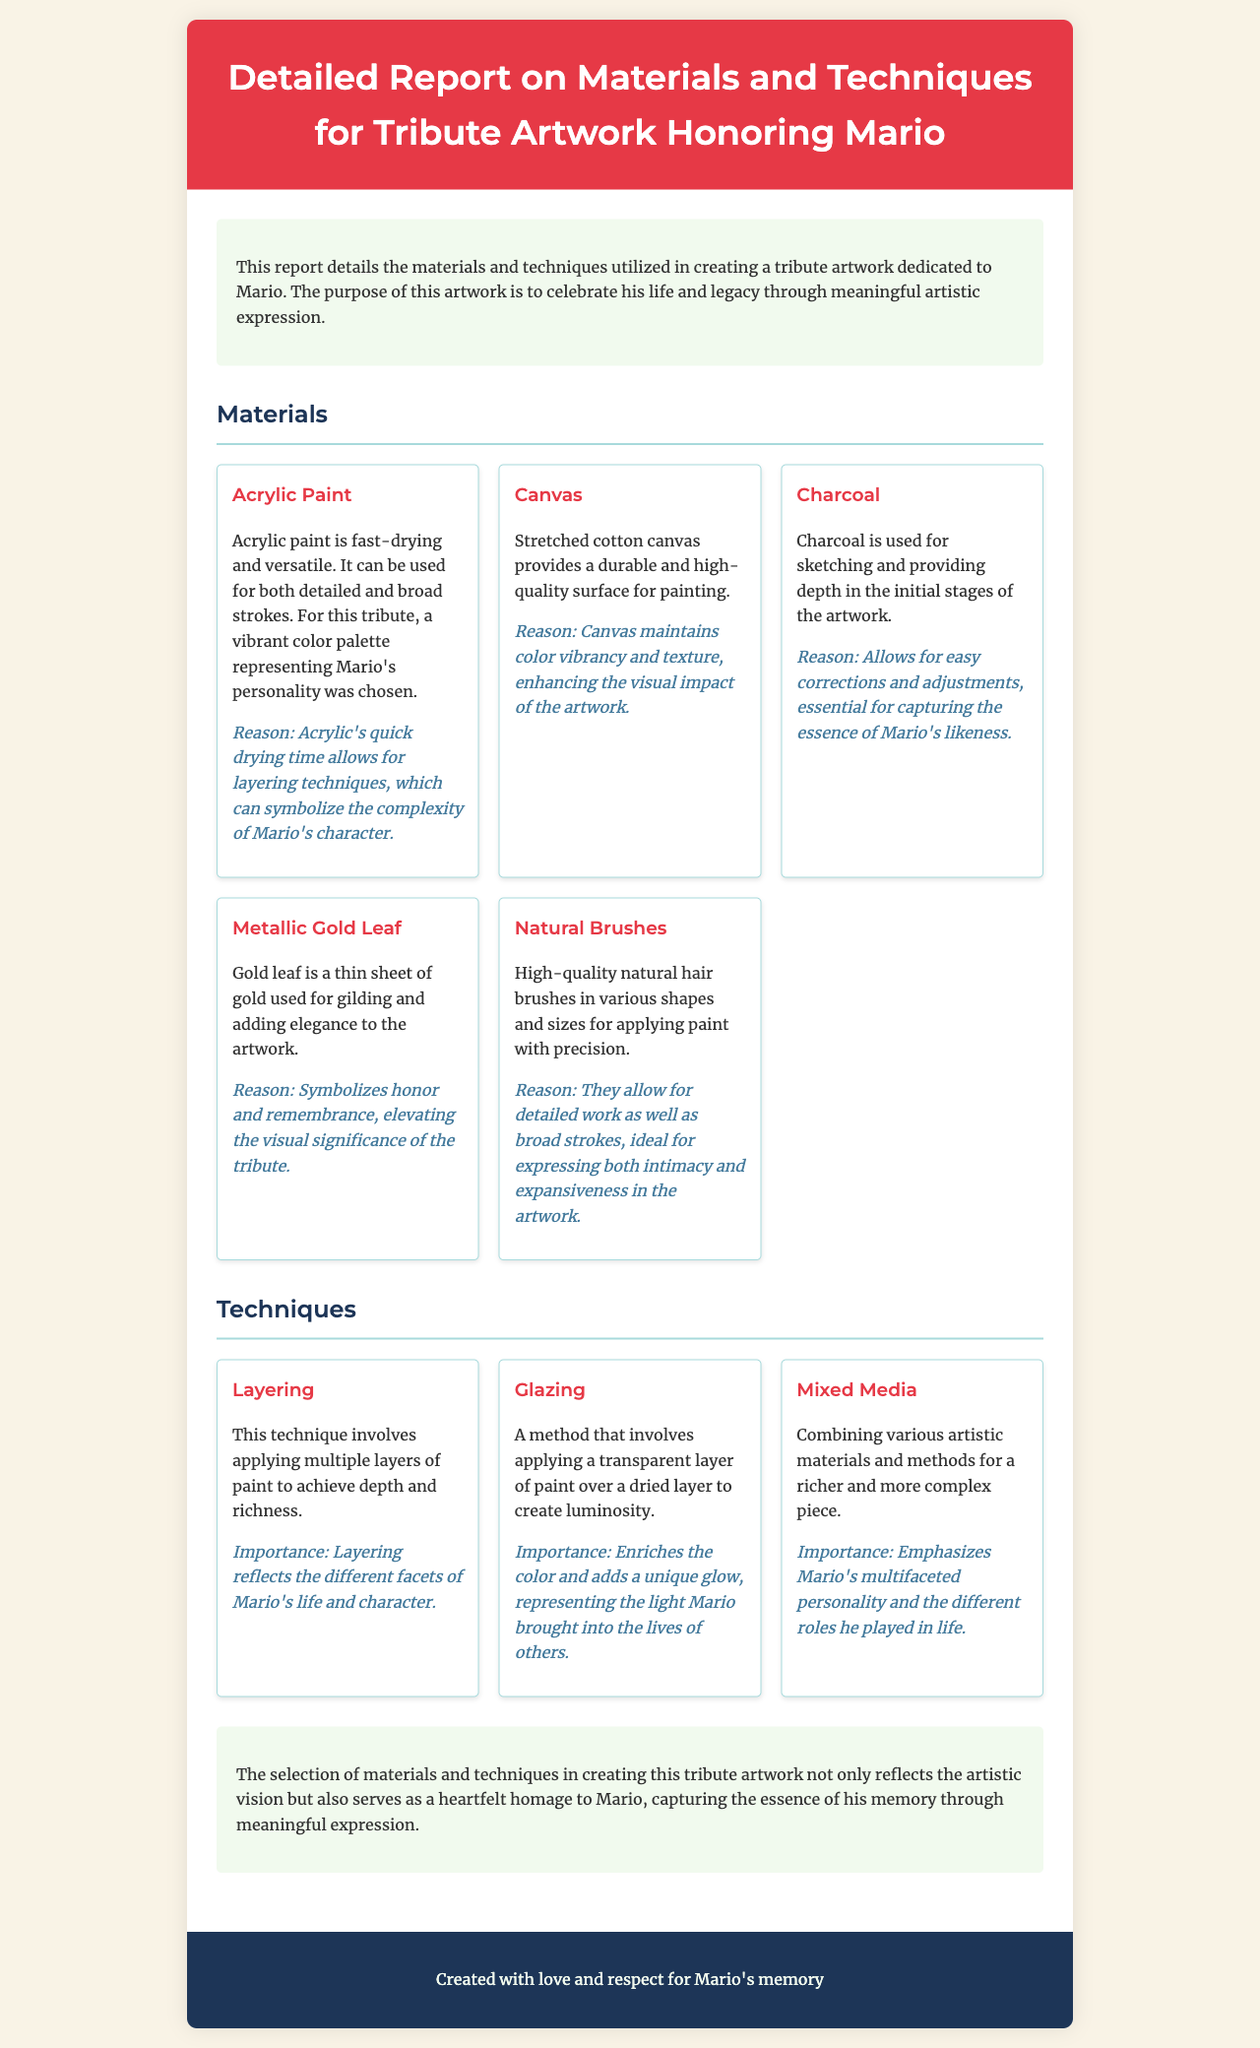What material provides a durable surface for painting? The document mentions that stretched cotton canvas provides a durable and high-quality surface for painting.
Answer: Canvas Which technique adds a unique glow to the artwork? The technique of glazing involves applying a transparent layer of paint to create luminosity, which adds a unique glow.
Answer: Glazing What color palette was chosen for the tribute artwork? The vibrant color palette was chosen to represent Mario's personality in the artwork.
Answer: Vibrant color palette How many techniques are described in the report? The document lists three techniques used in creating the tribute artwork.
Answer: Three What does metallic gold leaf symbolize in the artwork? The document states that gold leaf symbolizes honor and remembrance in the tribute artwork.
Answer: Honor and remembrance Which material is used for sketching in the initial stages? The report indicates that charcoal is used for sketching and providing depth in the initial stages of the artwork.
Answer: Charcoal What artistic method combines various materials for a richer piece? The mixed media technique consists of combining various artistic materials and methods for a richer and more complex piece.
Answer: Mixed Media What is the importance of the layering technique? Layering reflects the different facets of Mario's life and character according to the document's explanation.
Answer: Different facets of Mario's life and character 